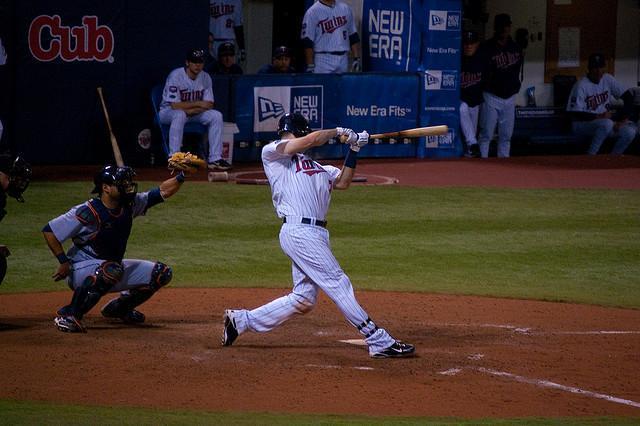How many people can you see?
Give a very brief answer. 7. How many oxygen tubes is the man in the bed wearing?
Give a very brief answer. 0. 